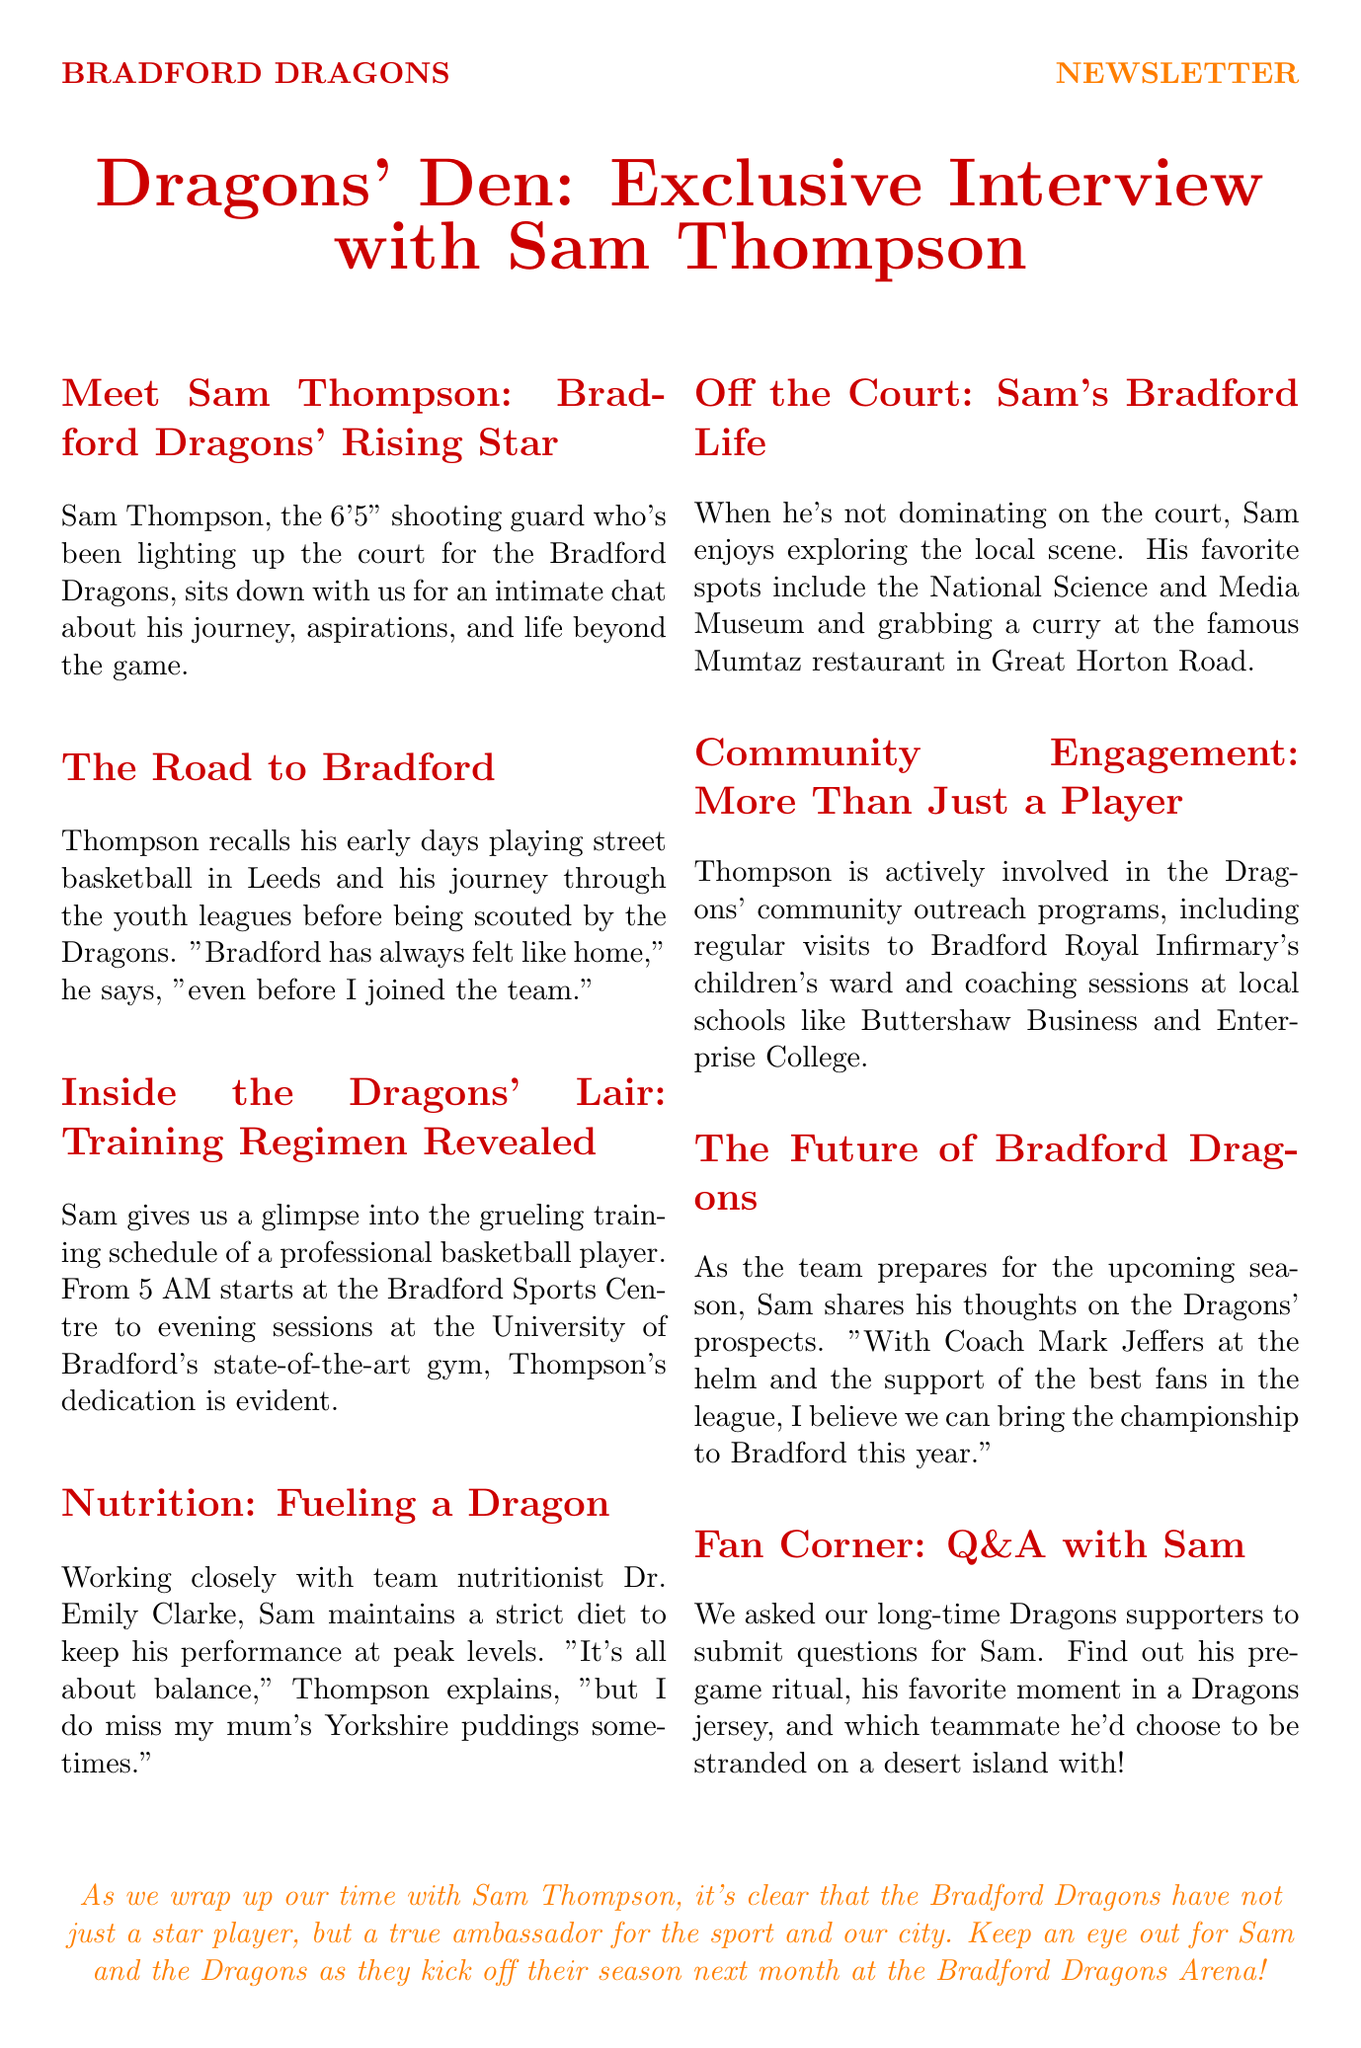What is Sam Thompson's height? Sam Thompson is described as a 6'5" shooting guard in the document.
Answer: 6'5" Where did Sam start playing basketball? Thompson recalls playing street basketball in Leeds during his early days.
Answer: Leeds What is the first training time mentioned for Sam? The document states that Sam starts training at 5 AM at the Bradford Sports Centre.
Answer: 5 AM Who is Sam's team nutritionist? The newsletter mentions Dr. Emily Clarke as the team nutritionist working with Sam.
Answer: Dr. Emily Clarke What is one of Sam's favorite local spots? Sam enjoys the National Science and Media Museum as one of his favorite places in Bradford.
Answer: National Science and Media Museum Which college does Sam conduct coaching sessions at? Sam is involved in coaching at Buttershaw Business and Enterprise College.
Answer: Buttershaw Business and Enterprise College What does Sam say about the championship prospects? Sam is optimistic about bringing the championship to Bradford this year.
Answer: Championship What is Sam's feeling about his mom's Yorkshire puddings? Sam expresses that he misses his mum's Yorkshire puddings sometimes.
Answer: Misses What type of engagement does Sam participate in outside basketball? Sam is actively involved in community outreach programs, such as visits to children's wards.
Answer: Community outreach programs 